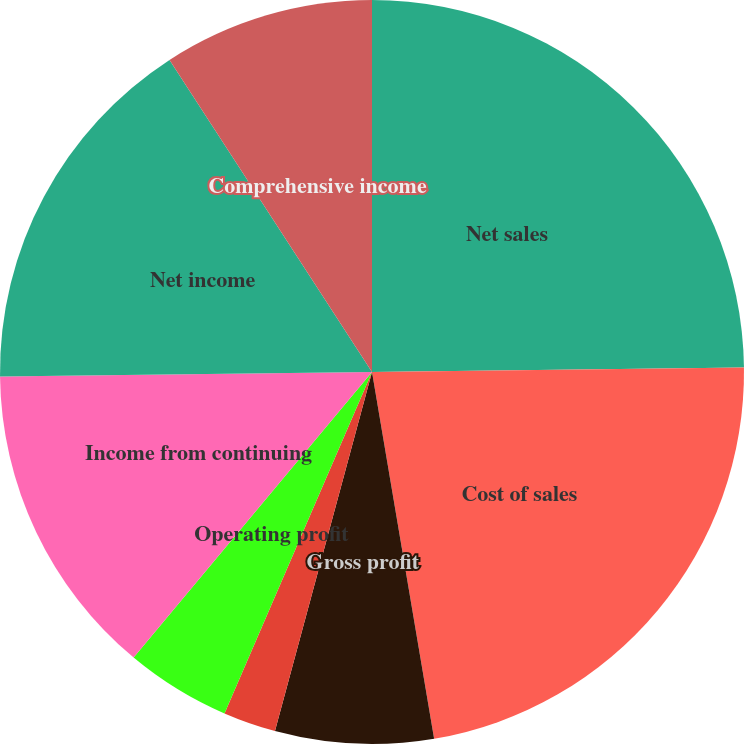<chart> <loc_0><loc_0><loc_500><loc_500><pie_chart><fcel>Net sales<fcel>Cost of sales<fcel>Gross profit<fcel>Selling general and<fcel>Operating profit<fcel>Interest expense net<fcel>Income from continuing<fcel>Net income<fcel>Comprehensive income<nl><fcel>24.81%<fcel>22.52%<fcel>6.87%<fcel>2.29%<fcel>4.58%<fcel>0.0%<fcel>13.74%<fcel>16.03%<fcel>9.16%<nl></chart> 